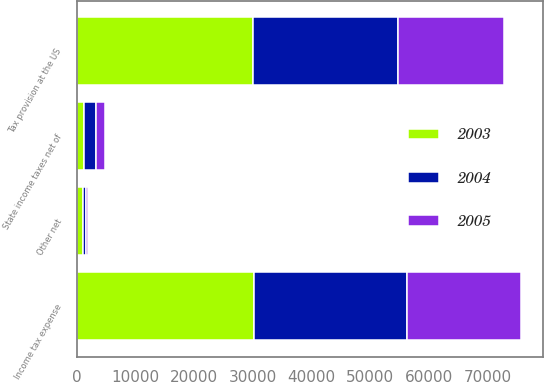Convert chart. <chart><loc_0><loc_0><loc_500><loc_500><stacked_bar_chart><ecel><fcel>Tax provision at the US<fcel>State income taxes net of<fcel>Other net<fcel>Income tax expense<nl><fcel>2003<fcel>30050<fcel>1230<fcel>1056<fcel>30224<nl><fcel>2004<fcel>24600<fcel>1975<fcel>600<fcel>25975<nl><fcel>2005<fcel>18163<fcel>1602<fcel>261<fcel>19504<nl></chart> 